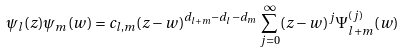Convert formula to latex. <formula><loc_0><loc_0><loc_500><loc_500>\psi _ { l } ( z ) \psi _ { m } ( w ) & = c _ { l , m } ( z - w ) ^ { d _ { l + m } - d _ { l } - d _ { m } } \sum _ { j = 0 } ^ { \infty } ( z - w ) ^ { j } \Psi _ { l + m } ^ { ( j ) } ( w )</formula> 